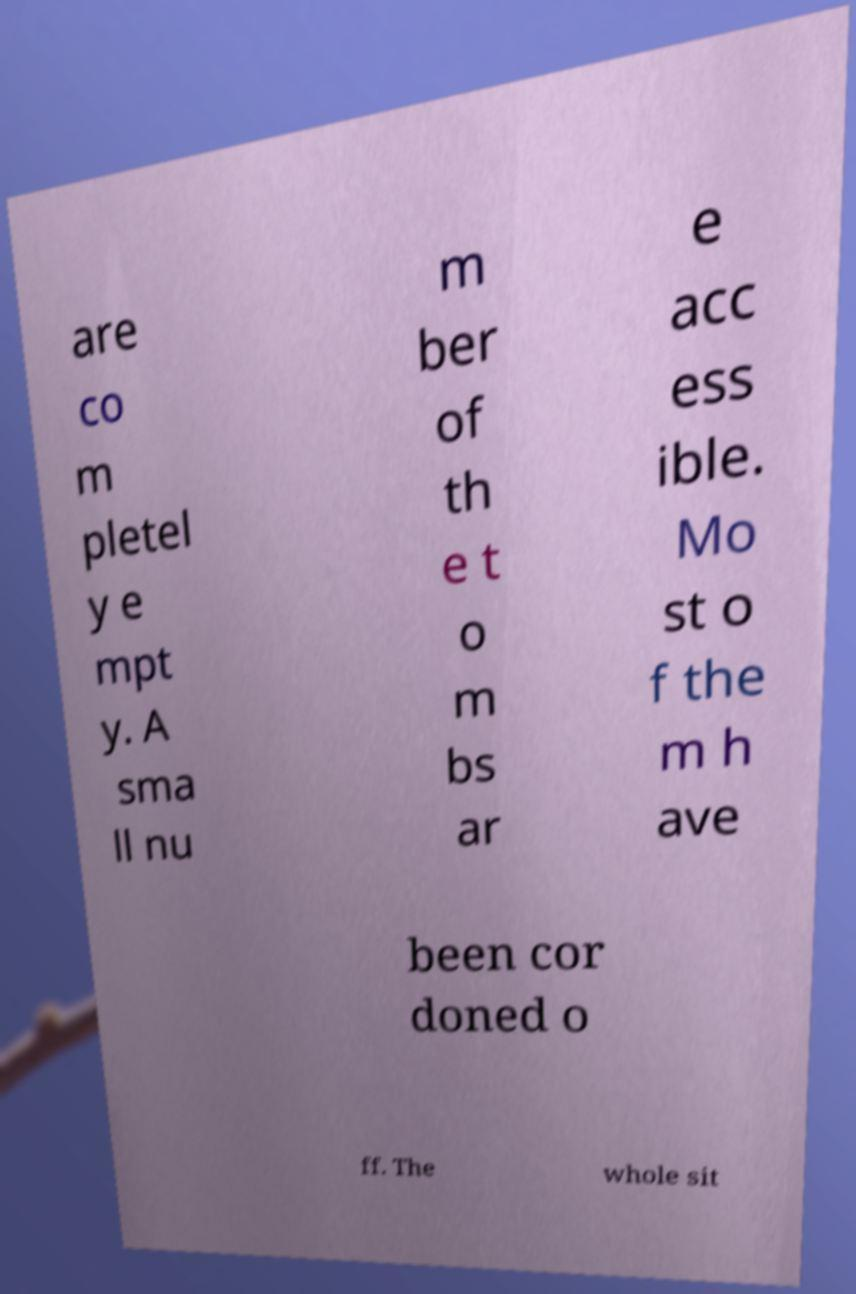Please identify and transcribe the text found in this image. are co m pletel y e mpt y. A sma ll nu m ber of th e t o m bs ar e acc ess ible. Mo st o f the m h ave been cor doned o ff. The whole sit 